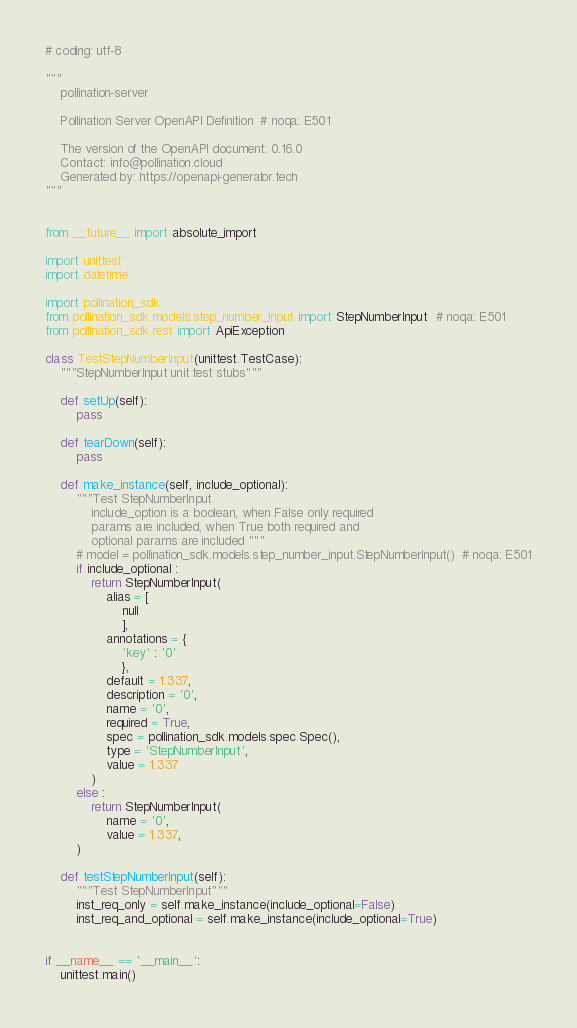<code> <loc_0><loc_0><loc_500><loc_500><_Python_># coding: utf-8

"""
    pollination-server

    Pollination Server OpenAPI Definition  # noqa: E501

    The version of the OpenAPI document: 0.16.0
    Contact: info@pollination.cloud
    Generated by: https://openapi-generator.tech
"""


from __future__ import absolute_import

import unittest
import datetime

import pollination_sdk
from pollination_sdk.models.step_number_input import StepNumberInput  # noqa: E501
from pollination_sdk.rest import ApiException

class TestStepNumberInput(unittest.TestCase):
    """StepNumberInput unit test stubs"""

    def setUp(self):
        pass

    def tearDown(self):
        pass

    def make_instance(self, include_optional):
        """Test StepNumberInput
            include_option is a boolean, when False only required
            params are included, when True both required and
            optional params are included """
        # model = pollination_sdk.models.step_number_input.StepNumberInput()  # noqa: E501
        if include_optional :
            return StepNumberInput(
                alias = [
                    null
                    ], 
                annotations = {
                    'key' : '0'
                    }, 
                default = 1.337, 
                description = '0', 
                name = '0', 
                required = True, 
                spec = pollination_sdk.models.spec.Spec(), 
                type = 'StepNumberInput', 
                value = 1.337
            )
        else :
            return StepNumberInput(
                name = '0',
                value = 1.337,
        )

    def testStepNumberInput(self):
        """Test StepNumberInput"""
        inst_req_only = self.make_instance(include_optional=False)
        inst_req_and_optional = self.make_instance(include_optional=True)


if __name__ == '__main__':
    unittest.main()
</code> 